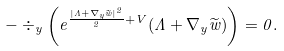Convert formula to latex. <formula><loc_0><loc_0><loc_500><loc_500>- \div _ { y } \left ( e ^ { \frac { | \Lambda + \nabla _ { y } \widetilde { w } | ^ { 2 } } { 2 } + V } ( \Lambda + \nabla _ { y } \widetilde { w } ) \right ) = 0 .</formula> 